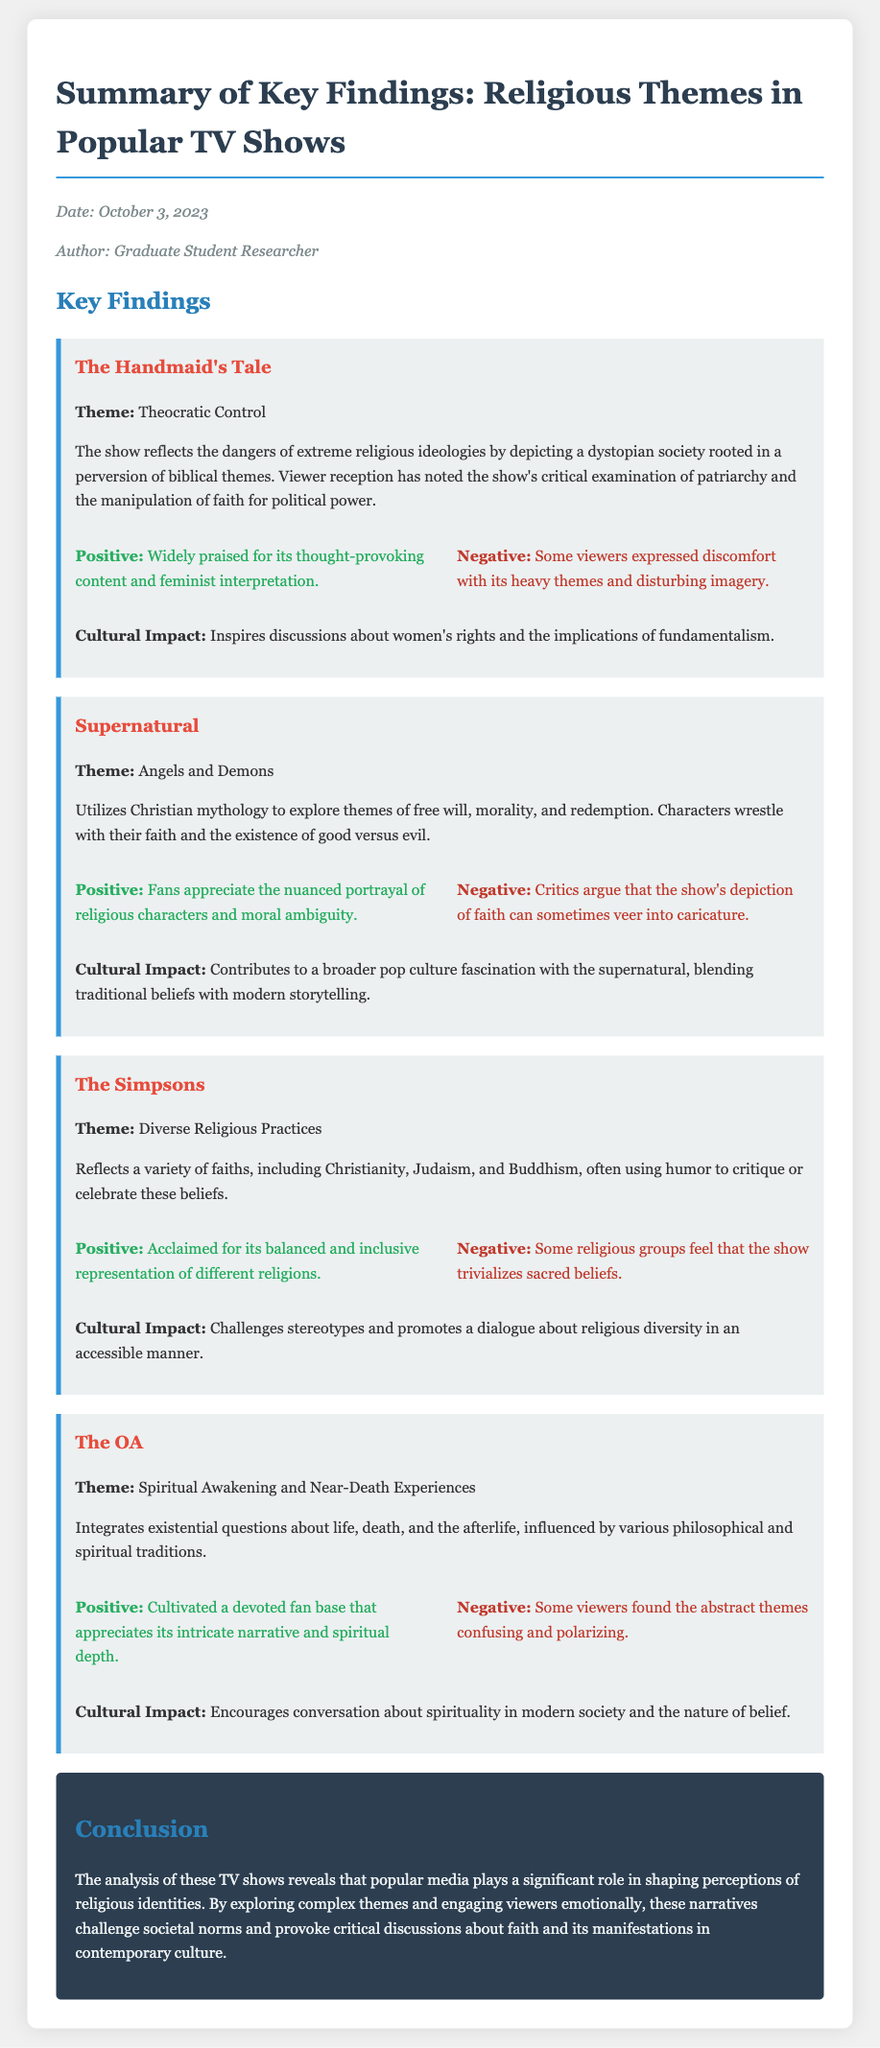What is the date of the memo? The date of the memo is explicitly stated in the document metadata.
Answer: October 3, 2023 Who is the author of the memo? The author is mentioned in the document's metadata section.
Answer: Graduate Student Researcher What is the theme of "The Handmaid's Tale"? Each show in the memo has a designated theme that summarizes its core message, which is specified within the show's description.
Answer: Theocratic Control What is one positive reception noted for "Supernatural"? Positive aspects of viewer reception are clearly outlined in the memo for each show, providing details of audience feedback.
Answer: Fans appreciate the nuanced portrayal of religious characters and moral ambiguity What is one cultural impact of "The Simpsons"? The cultural impact section addresses how each show influences societal conversations related to religious themes.
Answer: Challenges stereotypes and promotes a dialogue about religious diversity in an accessible manner What aspect of religion does "The OA" explore? Each show has a specific angle on religion as stated in the memo that ties back to its thematic content.
Answer: Spiritual Awakening and Near-Death Experiences How do viewers generally feel about the heavy themes in "The Handmaid's Tale"? The document provides insight into audience sentiment regarding various shows, highlighting both positive and negative reactions.
Answer: Some viewers expressed discomfort with its heavy themes and disturbing imagery What is the cultural influence discussed for "The OA"? The cultural impact related to each show is explicitly mentioned, revealing its significance in societal discourse.
Answer: Encourages conversation about spirituality in modern society and the nature of belief What kind of narrative does "The OA" provide? The document describes the types of narratives presented in each show, summarizing their storytelling approach.
Answer: Intricate narrative and spiritual depth 